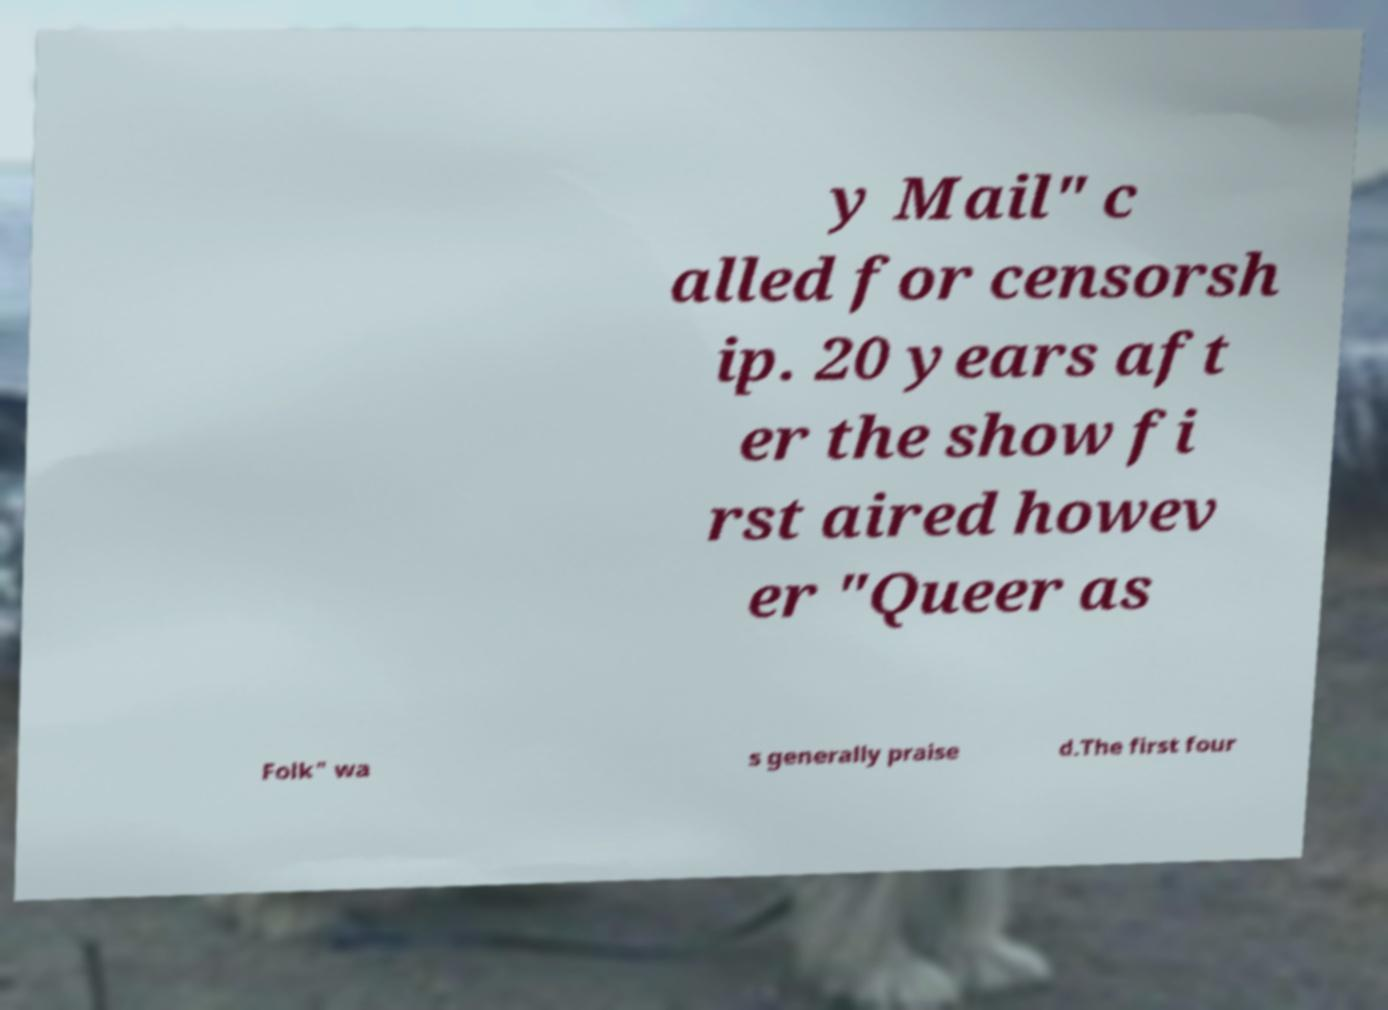What messages or text are displayed in this image? I need them in a readable, typed format. y Mail" c alled for censorsh ip. 20 years aft er the show fi rst aired howev er "Queer as Folk" wa s generally praise d.The first four 